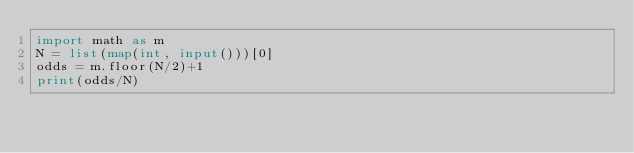<code> <loc_0><loc_0><loc_500><loc_500><_Python_>import math as m
N = list(map(int, input()))[0]
odds = m.floor(N/2)+1
print(odds/N)</code> 